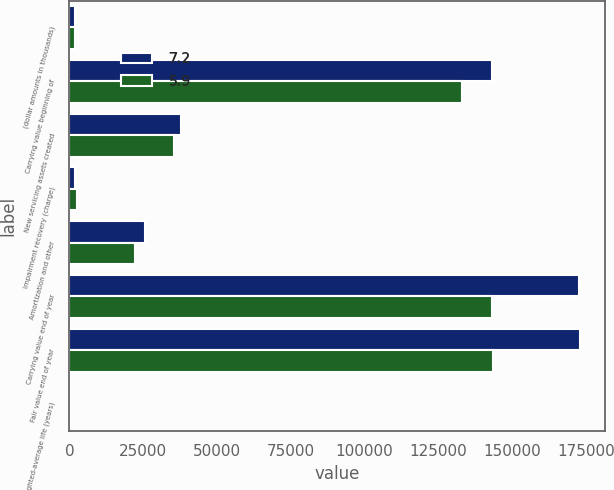Convert chart. <chart><loc_0><loc_0><loc_500><loc_500><stacked_bar_chart><ecel><fcel>(dollar amounts in thousands)<fcel>Carrying value beginning of<fcel>New servicing assets created<fcel>Impairment recovery (charge)<fcel>Amortization and other<fcel>Carrying value end of year<fcel>Fair value end of year<fcel>Weighted-average life (years)<nl><fcel>7.2<fcel>2016<fcel>143133<fcel>37813<fcel>1918<fcel>25715<fcel>172466<fcel>172779<fcel>7.2<nl><fcel>5.9<fcel>2015<fcel>132812<fcel>35407<fcel>2732<fcel>22354<fcel>143133<fcel>143435<fcel>5.9<nl></chart> 